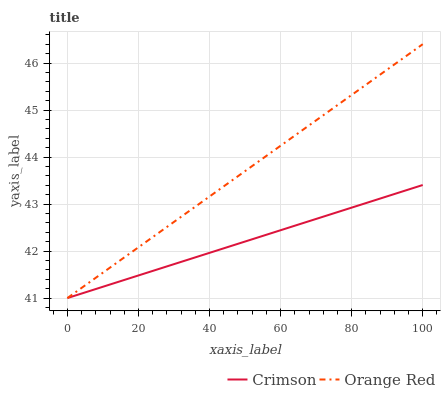Does Crimson have the minimum area under the curve?
Answer yes or no. Yes. Does Orange Red have the maximum area under the curve?
Answer yes or no. Yes. Does Orange Red have the minimum area under the curve?
Answer yes or no. No. Is Orange Red the smoothest?
Answer yes or no. Yes. Is Crimson the roughest?
Answer yes or no. Yes. Is Orange Red the roughest?
Answer yes or no. No. Does Orange Red have the highest value?
Answer yes or no. Yes. Does Orange Red intersect Crimson?
Answer yes or no. Yes. Is Orange Red less than Crimson?
Answer yes or no. No. Is Orange Red greater than Crimson?
Answer yes or no. No. 